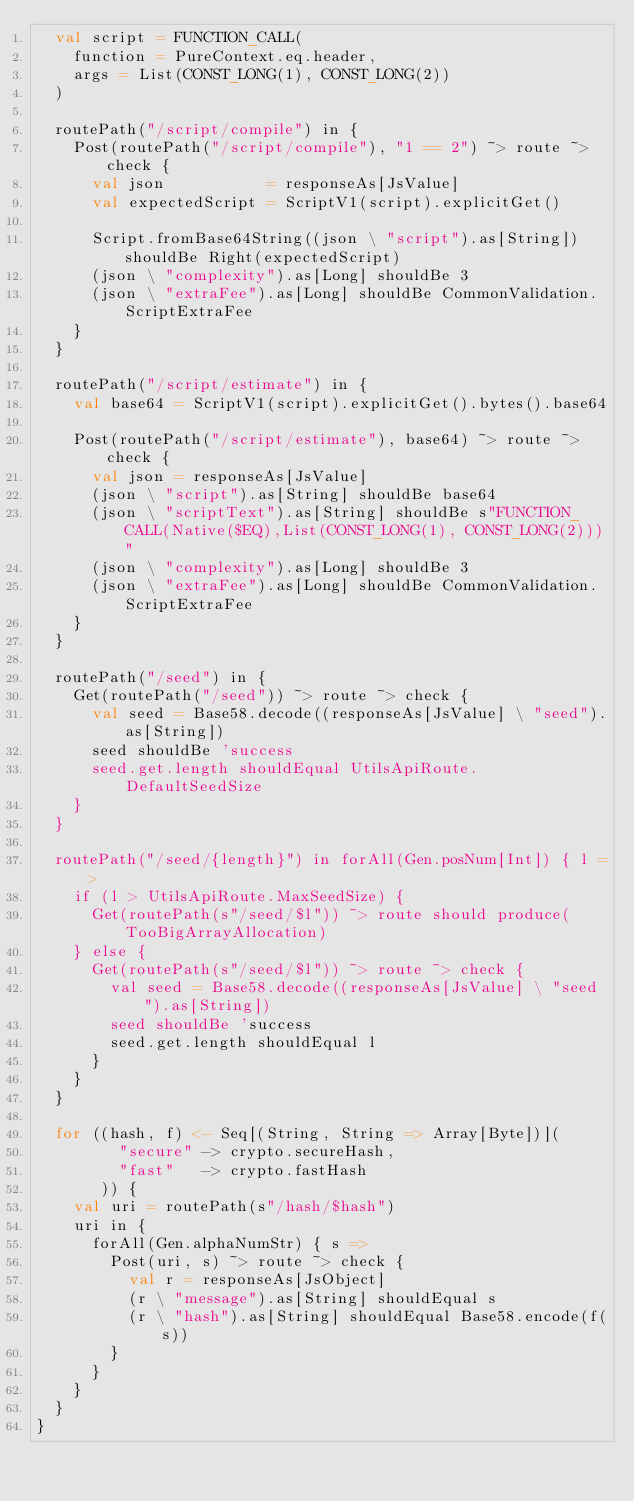<code> <loc_0><loc_0><loc_500><loc_500><_Scala_>  val script = FUNCTION_CALL(
    function = PureContext.eq.header,
    args = List(CONST_LONG(1), CONST_LONG(2))
  )

  routePath("/script/compile") in {
    Post(routePath("/script/compile"), "1 == 2") ~> route ~> check {
      val json           = responseAs[JsValue]
      val expectedScript = ScriptV1(script).explicitGet()

      Script.fromBase64String((json \ "script").as[String]) shouldBe Right(expectedScript)
      (json \ "complexity").as[Long] shouldBe 3
      (json \ "extraFee").as[Long] shouldBe CommonValidation.ScriptExtraFee
    }
  }

  routePath("/script/estimate") in {
    val base64 = ScriptV1(script).explicitGet().bytes().base64

    Post(routePath("/script/estimate"), base64) ~> route ~> check {
      val json = responseAs[JsValue]
      (json \ "script").as[String] shouldBe base64
      (json \ "scriptText").as[String] shouldBe s"FUNCTION_CALL(Native($EQ),List(CONST_LONG(1), CONST_LONG(2)))"
      (json \ "complexity").as[Long] shouldBe 3
      (json \ "extraFee").as[Long] shouldBe CommonValidation.ScriptExtraFee
    }
  }

  routePath("/seed") in {
    Get(routePath("/seed")) ~> route ~> check {
      val seed = Base58.decode((responseAs[JsValue] \ "seed").as[String])
      seed shouldBe 'success
      seed.get.length shouldEqual UtilsApiRoute.DefaultSeedSize
    }
  }

  routePath("/seed/{length}") in forAll(Gen.posNum[Int]) { l =>
    if (l > UtilsApiRoute.MaxSeedSize) {
      Get(routePath(s"/seed/$l")) ~> route should produce(TooBigArrayAllocation)
    } else {
      Get(routePath(s"/seed/$l")) ~> route ~> check {
        val seed = Base58.decode((responseAs[JsValue] \ "seed").as[String])
        seed shouldBe 'success
        seed.get.length shouldEqual l
      }
    }
  }

  for ((hash, f) <- Seq[(String, String => Array[Byte])](
         "secure" -> crypto.secureHash,
         "fast"   -> crypto.fastHash
       )) {
    val uri = routePath(s"/hash/$hash")
    uri in {
      forAll(Gen.alphaNumStr) { s =>
        Post(uri, s) ~> route ~> check {
          val r = responseAs[JsObject]
          (r \ "message").as[String] shouldEqual s
          (r \ "hash").as[String] shouldEqual Base58.encode(f(s))
        }
      }
    }
  }
}
</code> 